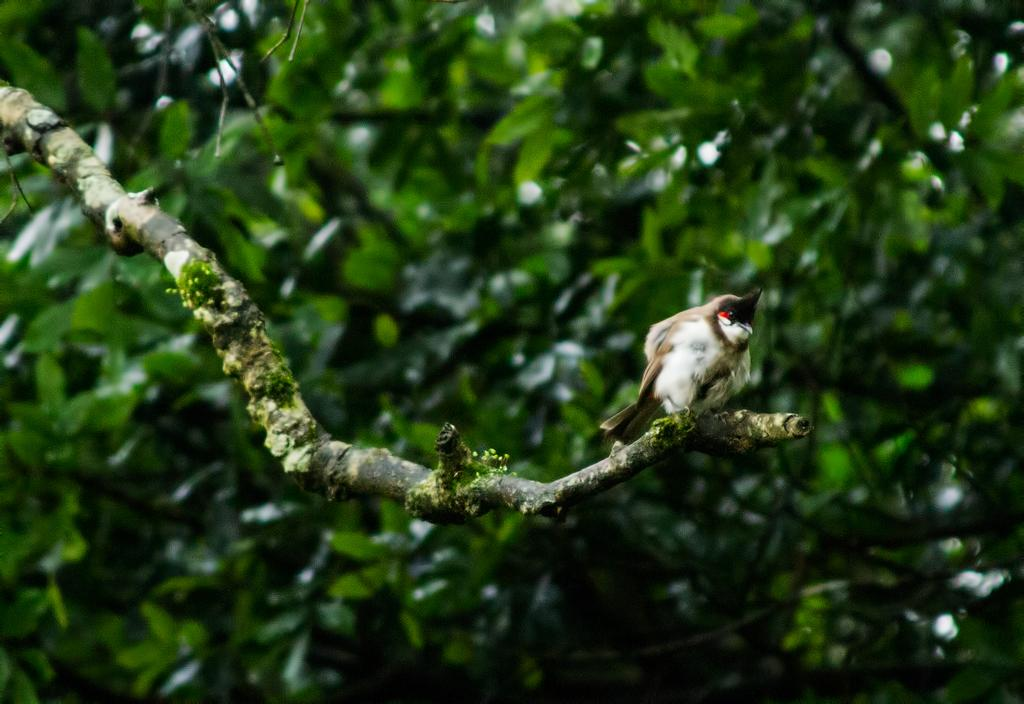What type of animal can be seen in the image? There is a bird in the image. Where is the bird located? The bird is on a branch. What can be seen in the background of the image? There are trees in the background of the image. How would you describe the background of the image? The background of the image is blurred. How many legs does the bird have in the image? The bird has two legs, but this question is unnecessary as the number of legs is not relevant to the image's content. 